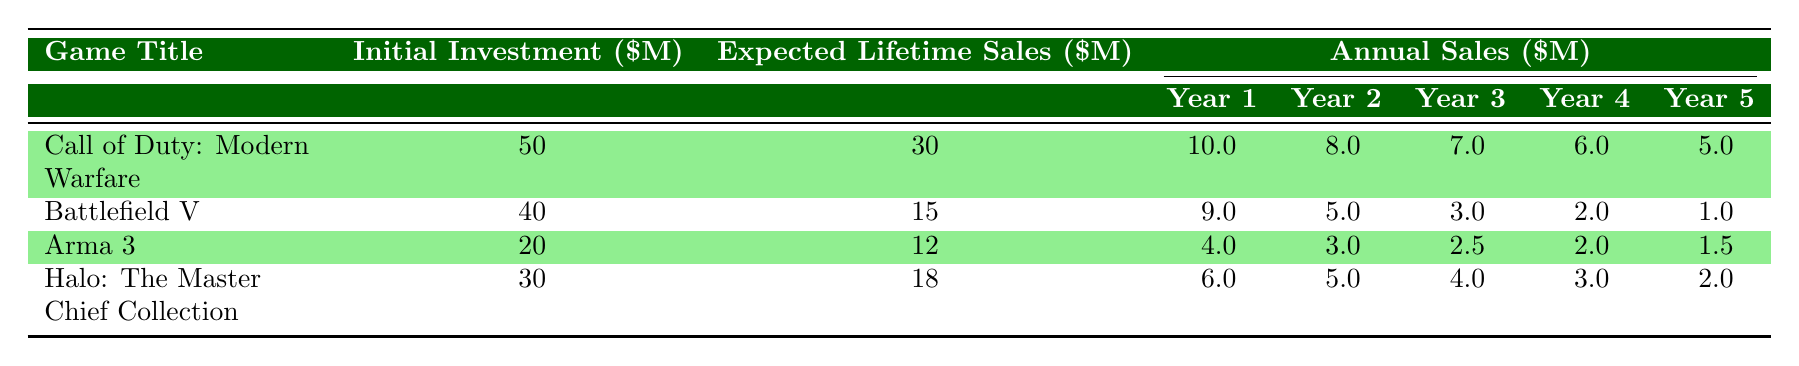What is the initial investment for "Call of Duty: Modern Warfare"? The initial investment for "Call of Duty: Modern Warfare" is found in the second column of its row. The value listed is 50 (in million dollars).
Answer: 50 Which game had the highest expected lifetime sales? By checking the expected lifetime sales column for each game, "Call of Duty: Modern Warfare" has 30 million, which is higher than the expected lifetime sales of the other games listed.
Answer: Call of Duty: Modern Warfare What are the total sales for "Battlefield V" over five years? To find the total sales for "Battlefield V", add up the annual sales values for each year: 9.0 + 5.0 + 3.0 + 2.0 + 1.0 = 20.0 million dollars.
Answer: 20.0 Is the annual sales in the first year higher for "Halo: The Master Chief Collection" than "Arma 3"? The annual sales in the first year for "Halo: The Master Chief Collection" is 6.0, while for "Arma 3" it is 4.0. Therefore, 6.0 is greater than 4.0, which makes this statement true.
Answer: Yes What is the average annual sales for "Arma 3" over the five years? To find the average, first sum the annual sales: 4.0 + 3.0 + 2.5 + 2.0 + 1.5 = 13.0 million. Then divide by the number of years: 13.0 / 5 = 2.6 million.
Answer: 2.6 Which game had the lowest sales in the fifth year? By looking at the fifth year sales for each game, "Battlefield V" has 1.0 million, which is the lowest compared to the others.
Answer: Battlefield V If we compare the total expected lifetime sales to the initial investment, which game has the lowest return on investment ratio? To find the return on investment (ROI) ratio for each game, divide the expected lifetime sales by the initial investment. "Call of Duty: Modern Warfare" has an ROI of 30000000/50000000 = 0.6, "Battlefield V" has 15000000/40000000 = 0.375, "Arma 3" has 12000000/20000000 = 0.6, and "Halo" has 18000000/30000000 = 0.6. "Battlefield V" has the lowest ratio of 0.375.
Answer: Battlefield V What is the total annual sales for all games combined in the fourth year? To get the total annual sales for the fourth year, add the sales from all games: 6.0 (Halo) + 2.0 (Battlefield) + 2.0 (Arma 3) + 3.0 (Call of Duty) = 13.0 million dollars.
Answer: 13.0 In what year did "Halo: The Master Chief Collection" achieve its highest sales? Checking the annual sales of "Halo: The Master Chief Collection", it achieved the highest sales in year 1 with 6.0 million, which is higher than sales in subsequent years.
Answer: Year 1 